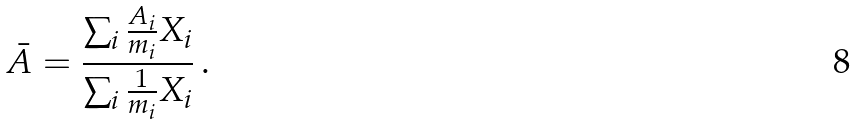Convert formula to latex. <formula><loc_0><loc_0><loc_500><loc_500>\bar { A } = \frac { \sum _ { i } \frac { A _ { i } } { m _ { i } } X _ { i } } { \sum _ { i } \frac { 1 } { m _ { i } } X _ { i } } \, .</formula> 